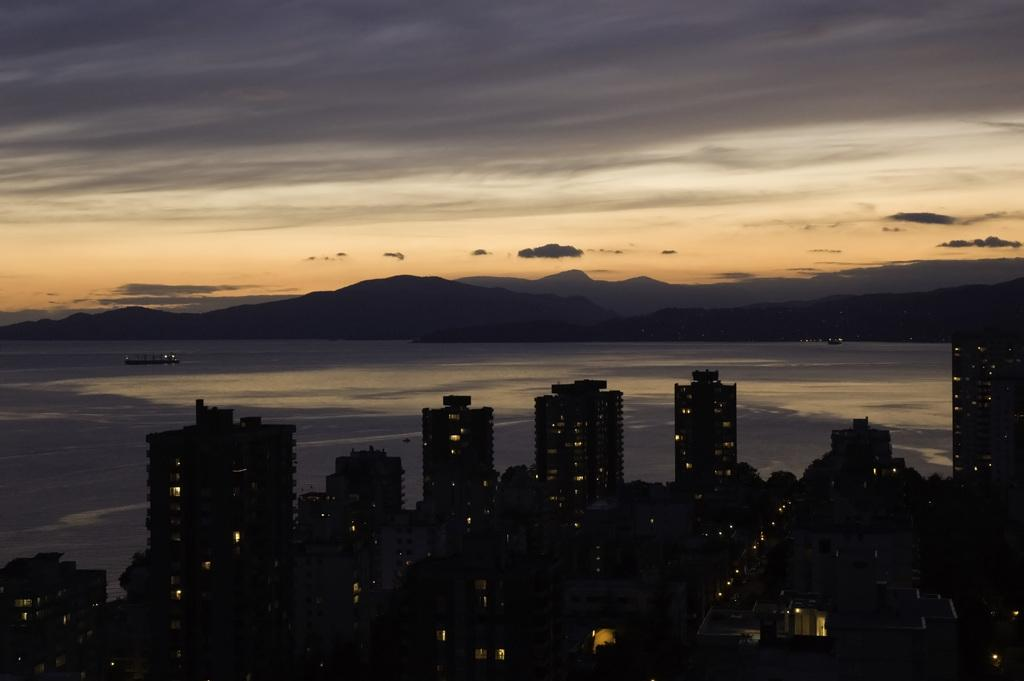What type of structures can be seen in the image? There are buildings in the image. What can be seen illuminated in the image? There are lights in the image. What natural feature is visible in the background of the image? There is water visible in the background, and there are mountains in the background as well. What is present on the surface of the water in the image? There are boats on the surface of the water. What part of the sky is visible in the image? The sky is visible in the background of the image. What type of stocking is the partner wearing in the image? There is no partner or stocking present in the image. What historical event is depicted in the image? There is no historical event depicted in the image; it features buildings, lights, water, boats, mountains, and the sky. 